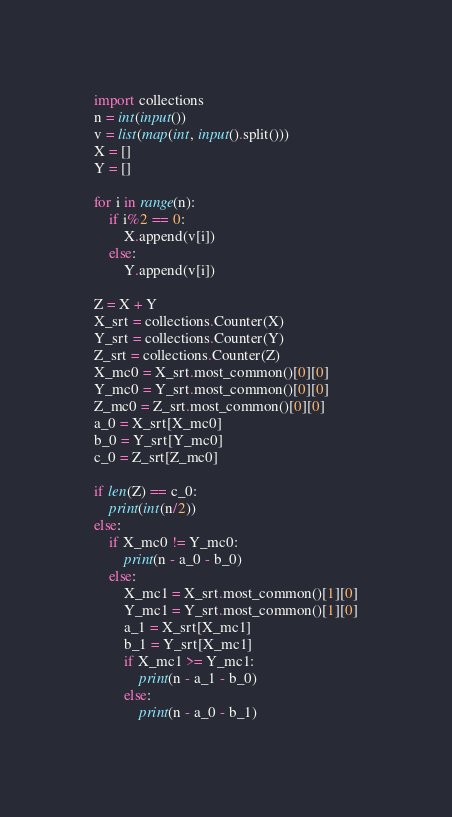<code> <loc_0><loc_0><loc_500><loc_500><_Python_>import collections
n = int(input())
v = list(map(int, input().split()))
X = []
Y = []

for i in range(n):
    if i%2 == 0:
        X.append(v[i])
    else:
        Y.append(v[i])

Z = X + Y
X_srt = collections.Counter(X)
Y_srt = collections.Counter(Y)
Z_srt = collections.Counter(Z)
X_mc0 = X_srt.most_common()[0][0]
Y_mc0 = Y_srt.most_common()[0][0]
Z_mc0 = Z_srt.most_common()[0][0]
a_0 = X_srt[X_mc0]
b_0 = Y_srt[Y_mc0]
c_0 = Z_srt[Z_mc0]

if len(Z) == c_0:
    print(int(n/2))
else:
    if X_mc0 != Y_mc0:
        print(n - a_0 - b_0)
    else:
        X_mc1 = X_srt.most_common()[1][0]
        Y_mc1 = Y_srt.most_common()[1][0]
        a_1 = X_srt[X_mc1]
        b_1 = Y_srt[X_mc1]
        if X_mc1 >= Y_mc1:
            print(n - a_1 - b_0)
        else:
            print(n - a_0 - b_1)</code> 